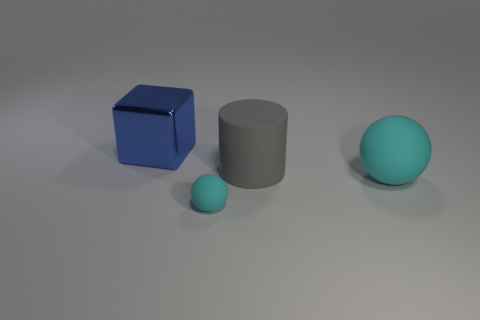Does the cyan rubber object that is to the right of the small sphere have the same shape as the cyan rubber thing that is on the left side of the large gray cylinder?
Ensure brevity in your answer.  Yes. There is a rubber sphere on the left side of the cyan thing right of the cyan matte object that is on the left side of the rubber cylinder; what color is it?
Give a very brief answer. Cyan. There is a ball to the right of the small ball; what color is it?
Offer a very short reply. Cyan. The sphere that is the same size as the gray object is what color?
Ensure brevity in your answer.  Cyan. Does the metallic cube have the same size as the gray cylinder?
Make the answer very short. Yes. What number of cyan rubber balls are on the right side of the large gray object?
Give a very brief answer. 1. What number of things are either spheres behind the tiny cyan ball or cyan rubber things?
Your response must be concise. 2. Is the number of large gray things that are right of the tiny cyan matte sphere greater than the number of metallic objects that are in front of the big cylinder?
Your response must be concise. Yes. There is a ball that is the same color as the small thing; what size is it?
Ensure brevity in your answer.  Large. Does the gray object have the same size as the ball that is right of the small matte ball?
Provide a short and direct response. Yes. 